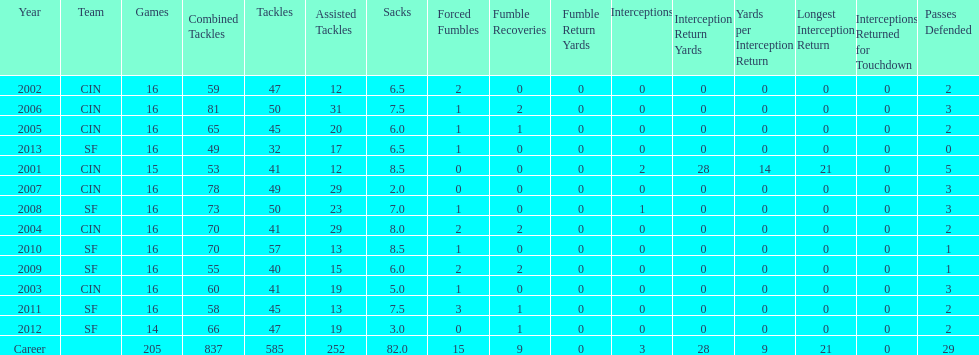For how many uninterrupted seasons has he played in sixteen games? 10. 